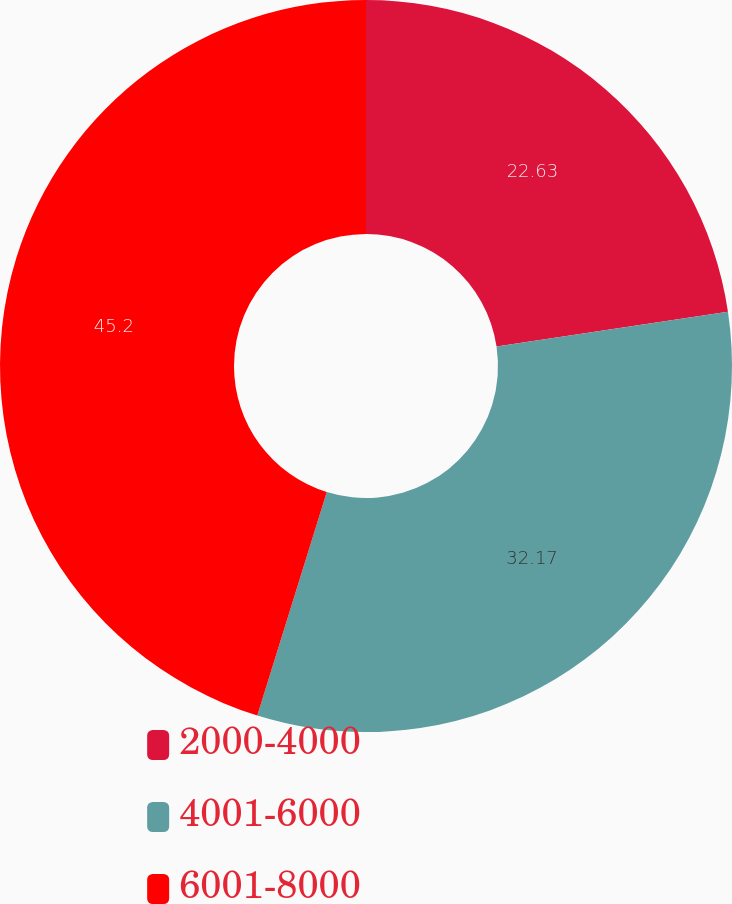Convert chart. <chart><loc_0><loc_0><loc_500><loc_500><pie_chart><fcel>2000-4000<fcel>4001-6000<fcel>6001-8000<nl><fcel>22.63%<fcel>32.17%<fcel>45.2%<nl></chart> 